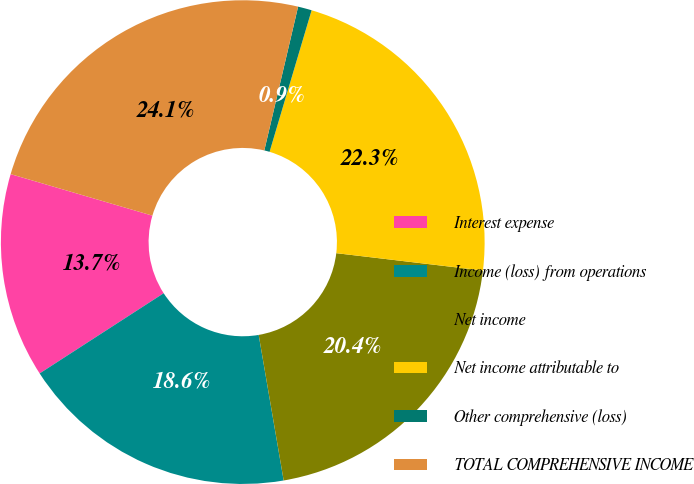Convert chart. <chart><loc_0><loc_0><loc_500><loc_500><pie_chart><fcel>Interest expense<fcel>Income (loss) from operations<fcel>Net income<fcel>Net income attributable to<fcel>Other comprehensive (loss)<fcel>TOTAL COMPREHENSIVE INCOME<nl><fcel>13.67%<fcel>18.57%<fcel>20.42%<fcel>22.28%<fcel>0.92%<fcel>24.14%<nl></chart> 